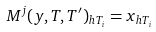Convert formula to latex. <formula><loc_0><loc_0><loc_500><loc_500>M ^ { j } ( y , T , T ^ { \prime } ) _ { h T _ { i } } = x _ { h T _ { i } }</formula> 